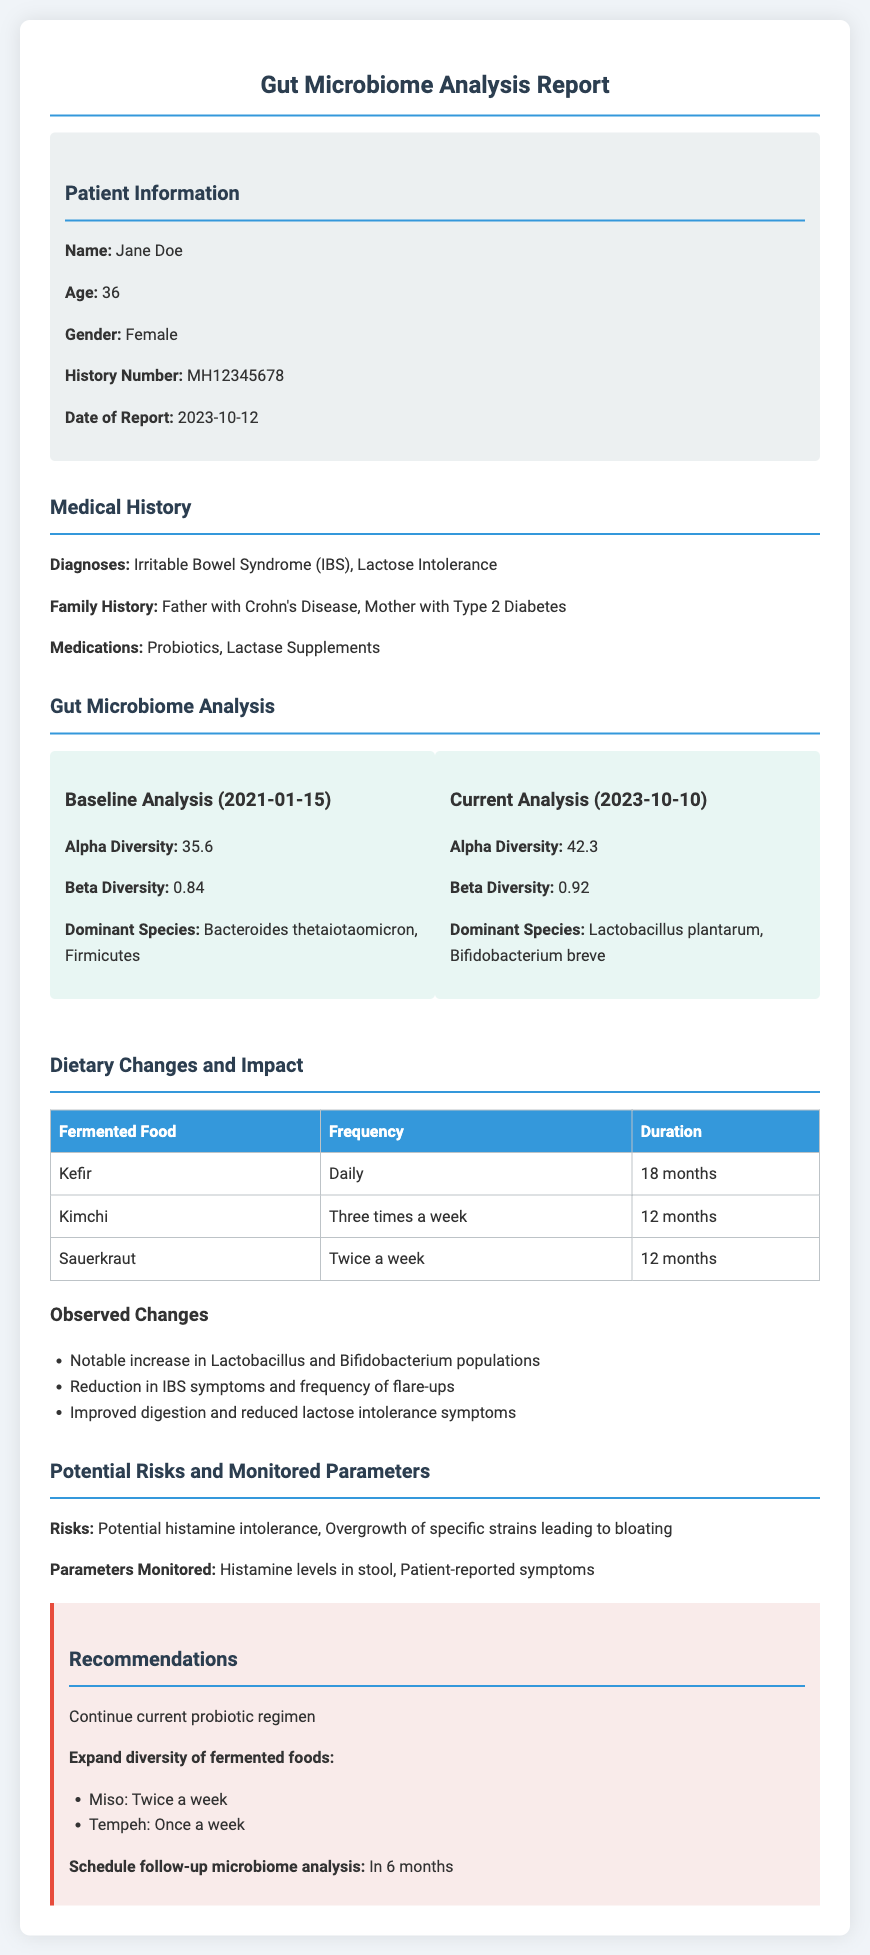What is the patient's name? The patient's name is mentioned in the patient information section of the document.
Answer: Jane Doe What is the date of the current analysis? The date of the current analysis is specified in the gut microbiome analysis section.
Answer: 2023-10-10 What is the alpha diversity in the baseline analysis? The alpha diversity in the baseline analysis is noted in the gut microbiome analysis section.
Answer: 35.6 How often does the patient consume kefir? The frequency of kefir consumption is listed under dietary changes in the document.
Answer: Daily What are the dominant species in the current analysis? The dominant species in the current analysis is found in the gut microbiome analysis section.
Answer: Lactobacillus plantarum, Bifidobacterium breve What changes were observed with fermented food consumption? The document lists observed changes in the patient’s microbiome and symptoms.
Answer: Notable increase in Lactobacillus and Bifidobacterium populations What is a potential risk mentioned in the document? A potential risk is referenced in the section discussing risks and monitored parameters.
Answer: Potential histamine intolerance What is recommended regarding the patient's probiotic regimen? The recommendations section includes guidance on the probiotic regimen.
Answer: Continue current probiotic regimen How long has the patient been consuming kimchi? The duration for kimchi consumption is mentioned in the dietary changes table.
Answer: 12 months 